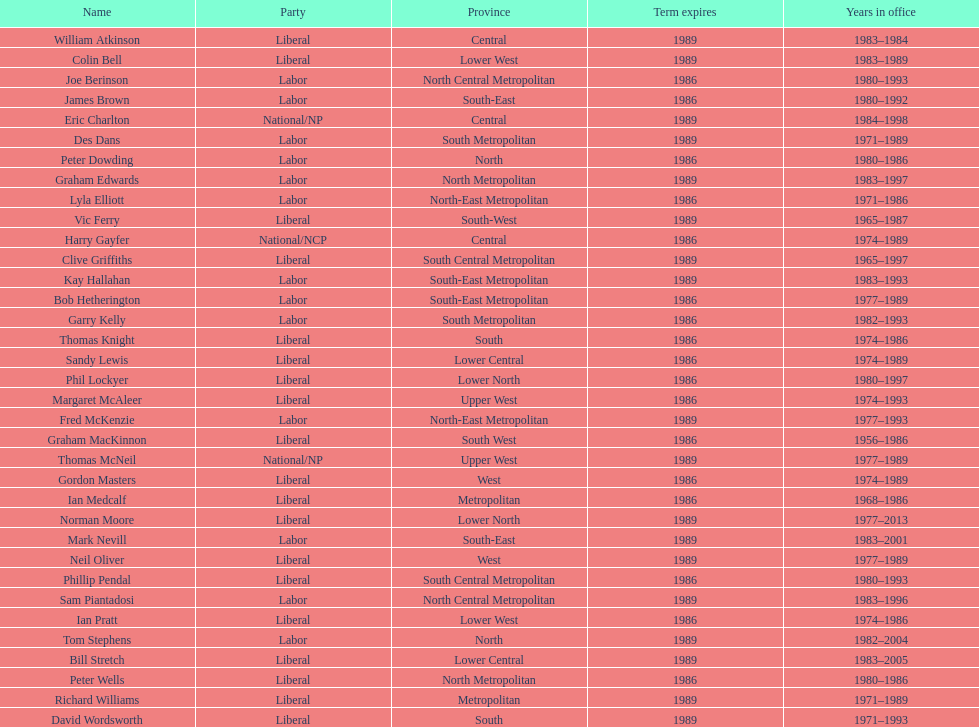Can you parse all the data within this table? {'header': ['Name', 'Party', 'Province', 'Term expires', 'Years in office'], 'rows': [['William Atkinson', 'Liberal', 'Central', '1989', '1983–1984'], ['Colin Bell', 'Liberal', 'Lower West', '1989', '1983–1989'], ['Joe Berinson', 'Labor', 'North Central Metropolitan', '1986', '1980–1993'], ['James Brown', 'Labor', 'South-East', '1986', '1980–1992'], ['Eric Charlton', 'National/NP', 'Central', '1989', '1984–1998'], ['Des Dans', 'Labor', 'South Metropolitan', '1989', '1971–1989'], ['Peter Dowding', 'Labor', 'North', '1986', '1980–1986'], ['Graham Edwards', 'Labor', 'North Metropolitan', '1989', '1983–1997'], ['Lyla Elliott', 'Labor', 'North-East Metropolitan', '1986', '1971–1986'], ['Vic Ferry', 'Liberal', 'South-West', '1989', '1965–1987'], ['Harry Gayfer', 'National/NCP', 'Central', '1986', '1974–1989'], ['Clive Griffiths', 'Liberal', 'South Central Metropolitan', '1989', '1965–1997'], ['Kay Hallahan', 'Labor', 'South-East Metropolitan', '1989', '1983–1993'], ['Bob Hetherington', 'Labor', 'South-East Metropolitan', '1986', '1977–1989'], ['Garry Kelly', 'Labor', 'South Metropolitan', '1986', '1982–1993'], ['Thomas Knight', 'Liberal', 'South', '1986', '1974–1986'], ['Sandy Lewis', 'Liberal', 'Lower Central', '1986', '1974–1989'], ['Phil Lockyer', 'Liberal', 'Lower North', '1986', '1980–1997'], ['Margaret McAleer', 'Liberal', 'Upper West', '1986', '1974–1993'], ['Fred McKenzie', 'Labor', 'North-East Metropolitan', '1989', '1977–1993'], ['Graham MacKinnon', 'Liberal', 'South West', '1986', '1956–1986'], ['Thomas McNeil', 'National/NP', 'Upper West', '1989', '1977–1989'], ['Gordon Masters', 'Liberal', 'West', '1986', '1974–1989'], ['Ian Medcalf', 'Liberal', 'Metropolitan', '1986', '1968–1986'], ['Norman Moore', 'Liberal', 'Lower North', '1989', '1977–2013'], ['Mark Nevill', 'Labor', 'South-East', '1989', '1983–2001'], ['Neil Oliver', 'Liberal', 'West', '1989', '1977–1989'], ['Phillip Pendal', 'Liberal', 'South Central Metropolitan', '1986', '1980–1993'], ['Sam Piantadosi', 'Labor', 'North Central Metropolitan', '1989', '1983–1996'], ['Ian Pratt', 'Liberal', 'Lower West', '1986', '1974–1986'], ['Tom Stephens', 'Labor', 'North', '1989', '1982–2004'], ['Bill Stretch', 'Liberal', 'Lower Central', '1989', '1983–2005'], ['Peter Wells', 'Liberal', 'North Metropolitan', '1986', '1980–1986'], ['Richard Williams', 'Liberal', 'Metropolitan', '1989', '1971–1989'], ['David Wordsworth', 'Liberal', 'South', '1989', '1971–1993']]} Which party has the most membership? Liberal. 